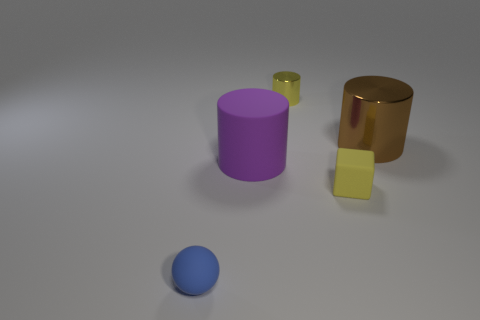What material is the tiny thing that is the same color as the small cylinder?
Keep it short and to the point. Rubber. Is the number of small blue objects behind the purple cylinder the same as the number of purple cylinders that are left of the blue sphere?
Keep it short and to the point. Yes. What is the size of the matte thing that is the same shape as the big brown metal thing?
Your response must be concise. Large. How big is the cylinder that is on the right side of the big matte cylinder and to the left of the yellow cube?
Give a very brief answer. Small. There is a tiny metallic cylinder; are there any small yellow objects in front of it?
Give a very brief answer. Yes. What number of objects are either metallic things that are in front of the tiny cylinder or big purple blocks?
Your answer should be very brief. 1. There is a big object that is to the left of the tiny yellow shiny thing; how many small yellow matte blocks are in front of it?
Give a very brief answer. 1. Is the number of purple objects behind the tiny shiny object less than the number of big rubber cylinders in front of the sphere?
Provide a short and direct response. No. What shape is the tiny rubber thing that is right of the yellow object that is behind the purple cylinder?
Offer a very short reply. Cube. What number of other things are the same material as the large brown thing?
Your response must be concise. 1. 